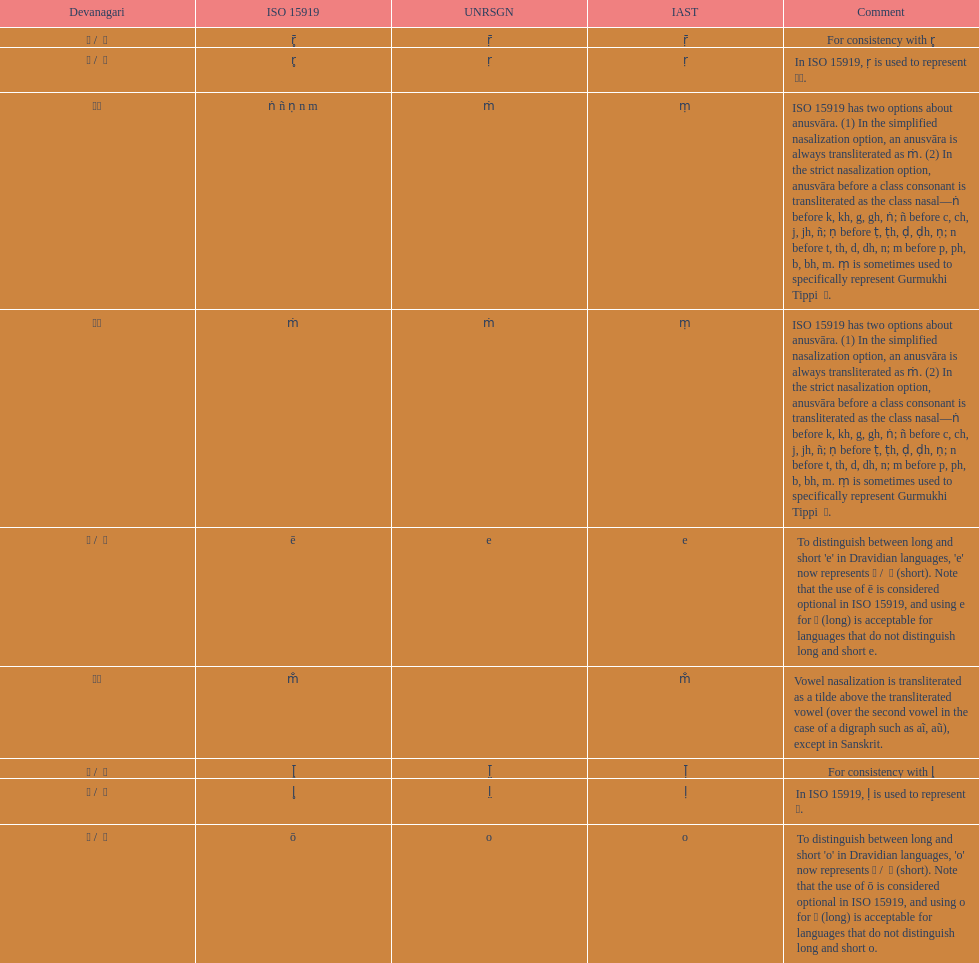What is listed previous to in iso 15919, &#7735; is used to represent &#2355;. under comments? For consistency with r̥. 